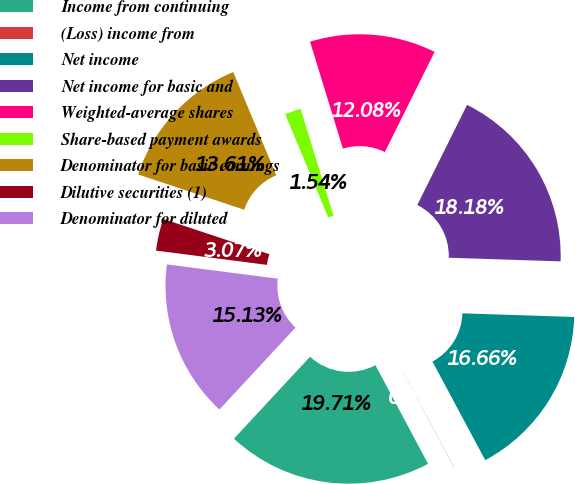Convert chart. <chart><loc_0><loc_0><loc_500><loc_500><pie_chart><fcel>Income from continuing<fcel>(Loss) income from<fcel>Net income<fcel>Net income for basic and<fcel>Weighted-average shares<fcel>Share-based payment awards<fcel>Denominator for basic earnings<fcel>Dilutive securities (1)<fcel>Denominator for diluted<nl><fcel>19.71%<fcel>0.02%<fcel>16.66%<fcel>18.18%<fcel>12.08%<fcel>1.54%<fcel>13.61%<fcel>3.07%<fcel>15.13%<nl></chart> 